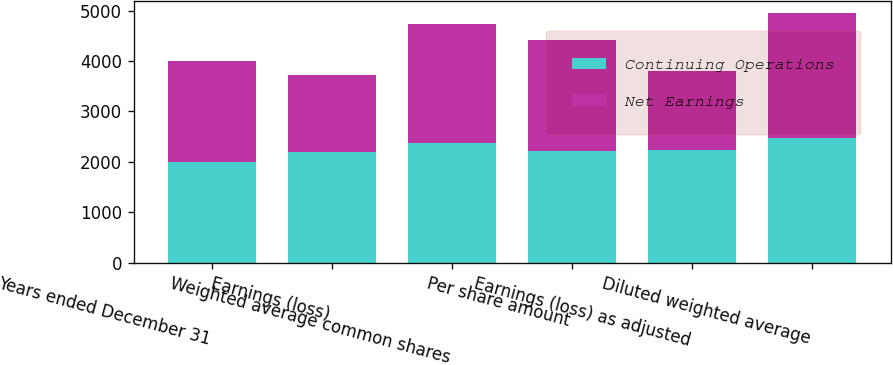Convert chart. <chart><loc_0><loc_0><loc_500><loc_500><stacked_bar_chart><ecel><fcel>Years ended December 31<fcel>Earnings (loss)<fcel>Weighted average common shares<fcel>Per share amount<fcel>Earnings (loss) as adjusted<fcel>Diluted weighted average<nl><fcel>Continuing Operations<fcel>2004<fcel>2191<fcel>2365<fcel>2212<fcel>2233<fcel>2472<nl><fcel>Net Earnings<fcel>2004<fcel>1532<fcel>2365<fcel>2212<fcel>1574<fcel>2472<nl></chart> 